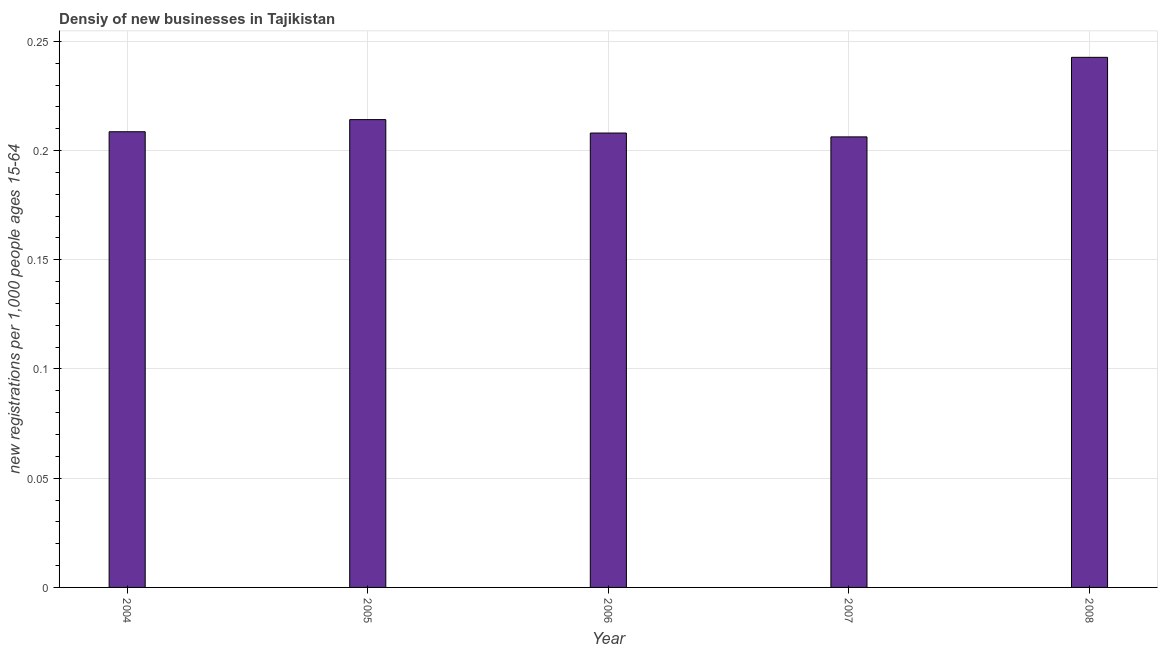Does the graph contain any zero values?
Make the answer very short. No. What is the title of the graph?
Your answer should be very brief. Densiy of new businesses in Tajikistan. What is the label or title of the Y-axis?
Offer a terse response. New registrations per 1,0 people ages 15-64. What is the density of new business in 2007?
Ensure brevity in your answer.  0.21. Across all years, what is the maximum density of new business?
Offer a terse response. 0.24. Across all years, what is the minimum density of new business?
Make the answer very short. 0.21. In which year was the density of new business minimum?
Offer a very short reply. 2007. What is the sum of the density of new business?
Provide a succinct answer. 1.08. What is the difference between the density of new business in 2004 and 2005?
Your answer should be compact. -0.01. What is the average density of new business per year?
Your response must be concise. 0.22. What is the median density of new business?
Make the answer very short. 0.21. In how many years, is the density of new business greater than 0.07 ?
Give a very brief answer. 5. Is the density of new business in 2005 less than that in 2006?
Give a very brief answer. No. What is the difference between the highest and the second highest density of new business?
Your answer should be very brief. 0.03. How many bars are there?
Keep it short and to the point. 5. How many years are there in the graph?
Your answer should be very brief. 5. What is the new registrations per 1,000 people ages 15-64 of 2004?
Provide a succinct answer. 0.21. What is the new registrations per 1,000 people ages 15-64 of 2005?
Your answer should be compact. 0.21. What is the new registrations per 1,000 people ages 15-64 of 2006?
Provide a short and direct response. 0.21. What is the new registrations per 1,000 people ages 15-64 in 2007?
Keep it short and to the point. 0.21. What is the new registrations per 1,000 people ages 15-64 in 2008?
Keep it short and to the point. 0.24. What is the difference between the new registrations per 1,000 people ages 15-64 in 2004 and 2005?
Provide a succinct answer. -0.01. What is the difference between the new registrations per 1,000 people ages 15-64 in 2004 and 2006?
Offer a very short reply. 0. What is the difference between the new registrations per 1,000 people ages 15-64 in 2004 and 2007?
Ensure brevity in your answer.  0. What is the difference between the new registrations per 1,000 people ages 15-64 in 2004 and 2008?
Provide a short and direct response. -0.03. What is the difference between the new registrations per 1,000 people ages 15-64 in 2005 and 2006?
Provide a short and direct response. 0.01. What is the difference between the new registrations per 1,000 people ages 15-64 in 2005 and 2007?
Your answer should be compact. 0.01. What is the difference between the new registrations per 1,000 people ages 15-64 in 2005 and 2008?
Make the answer very short. -0.03. What is the difference between the new registrations per 1,000 people ages 15-64 in 2006 and 2007?
Provide a short and direct response. 0. What is the difference between the new registrations per 1,000 people ages 15-64 in 2006 and 2008?
Your answer should be compact. -0.03. What is the difference between the new registrations per 1,000 people ages 15-64 in 2007 and 2008?
Give a very brief answer. -0.04. What is the ratio of the new registrations per 1,000 people ages 15-64 in 2004 to that in 2006?
Keep it short and to the point. 1. What is the ratio of the new registrations per 1,000 people ages 15-64 in 2004 to that in 2007?
Your response must be concise. 1.01. What is the ratio of the new registrations per 1,000 people ages 15-64 in 2004 to that in 2008?
Provide a succinct answer. 0.86. What is the ratio of the new registrations per 1,000 people ages 15-64 in 2005 to that in 2006?
Keep it short and to the point. 1.03. What is the ratio of the new registrations per 1,000 people ages 15-64 in 2005 to that in 2007?
Ensure brevity in your answer.  1.04. What is the ratio of the new registrations per 1,000 people ages 15-64 in 2005 to that in 2008?
Keep it short and to the point. 0.88. What is the ratio of the new registrations per 1,000 people ages 15-64 in 2006 to that in 2007?
Ensure brevity in your answer.  1.01. What is the ratio of the new registrations per 1,000 people ages 15-64 in 2006 to that in 2008?
Offer a very short reply. 0.86. 